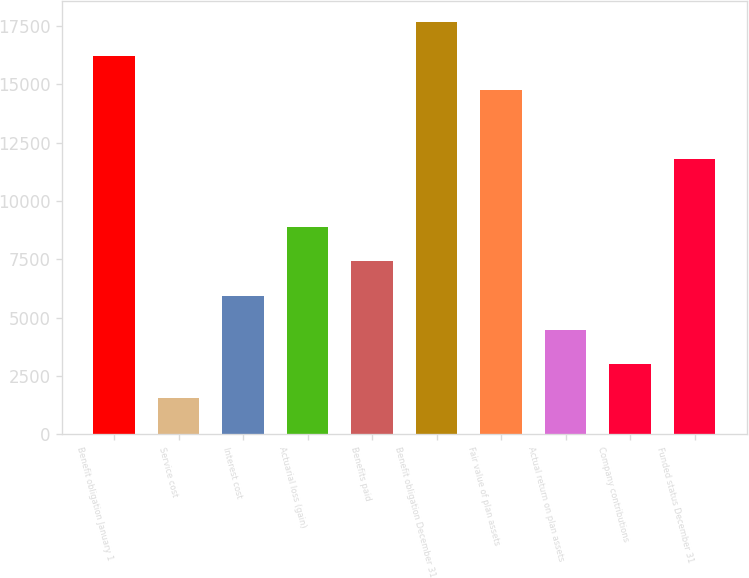Convert chart. <chart><loc_0><loc_0><loc_500><loc_500><bar_chart><fcel>Benefit obligation January 1<fcel>Service cost<fcel>Interest cost<fcel>Actuarial loss (gain)<fcel>Benefits paid<fcel>Benefit obligation December 31<fcel>Fair value of plan assets<fcel>Actual return on plan assets<fcel>Company contributions<fcel>Funded status December 31<nl><fcel>16208.9<fcel>1529.9<fcel>5933.6<fcel>8869.4<fcel>7401.5<fcel>17676.8<fcel>14741<fcel>4465.7<fcel>2997.8<fcel>11805.2<nl></chart> 